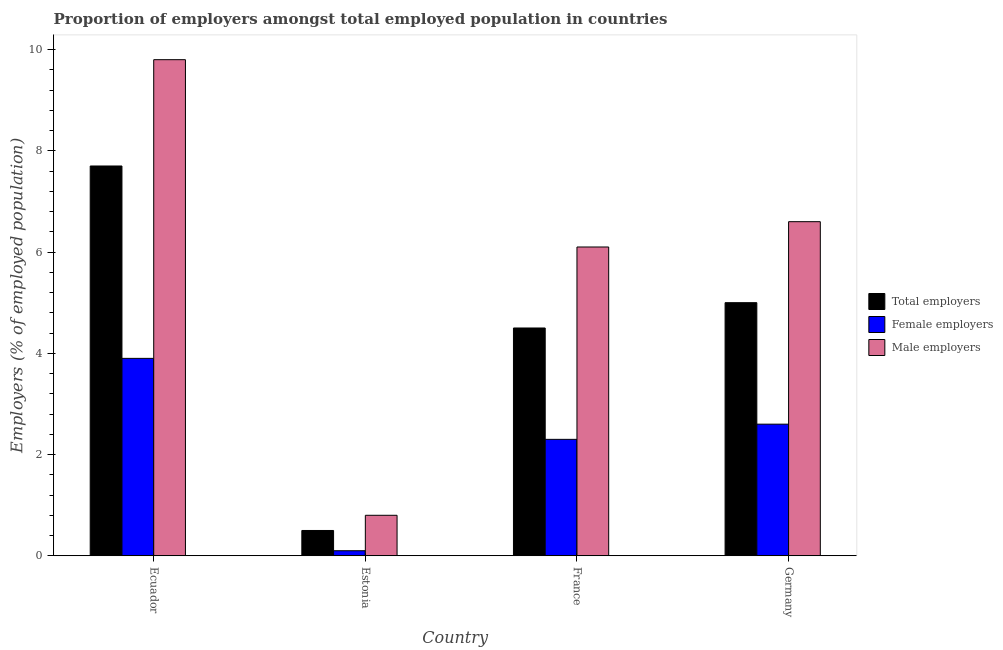How many bars are there on the 2nd tick from the left?
Your answer should be very brief. 3. What is the label of the 4th group of bars from the left?
Ensure brevity in your answer.  Germany. What is the percentage of total employers in Estonia?
Ensure brevity in your answer.  0.5. Across all countries, what is the maximum percentage of female employers?
Give a very brief answer. 3.9. In which country was the percentage of female employers maximum?
Your response must be concise. Ecuador. In which country was the percentage of total employers minimum?
Offer a very short reply. Estonia. What is the total percentage of male employers in the graph?
Make the answer very short. 23.3. What is the difference between the percentage of total employers in Ecuador and that in France?
Your answer should be compact. 3.2. What is the difference between the percentage of male employers in Ecuador and the percentage of female employers in France?
Offer a terse response. 7.5. What is the average percentage of male employers per country?
Offer a very short reply. 5.83. What is the difference between the percentage of total employers and percentage of female employers in France?
Make the answer very short. 2.2. What is the ratio of the percentage of total employers in Ecuador to that in Germany?
Your response must be concise. 1.54. What is the difference between the highest and the second highest percentage of male employers?
Provide a short and direct response. 3.2. What is the difference between the highest and the lowest percentage of total employers?
Make the answer very short. 7.2. In how many countries, is the percentage of male employers greater than the average percentage of male employers taken over all countries?
Offer a terse response. 3. What does the 2nd bar from the left in France represents?
Give a very brief answer. Female employers. What does the 1st bar from the right in France represents?
Your answer should be compact. Male employers. Is it the case that in every country, the sum of the percentage of total employers and percentage of female employers is greater than the percentage of male employers?
Provide a succinct answer. No. How many bars are there?
Provide a short and direct response. 12. Are all the bars in the graph horizontal?
Provide a succinct answer. No. What is the difference between two consecutive major ticks on the Y-axis?
Offer a terse response. 2. Does the graph contain grids?
Offer a terse response. No. Where does the legend appear in the graph?
Keep it short and to the point. Center right. What is the title of the graph?
Offer a very short reply. Proportion of employers amongst total employed population in countries. Does "Refusal of sex" appear as one of the legend labels in the graph?
Your answer should be very brief. No. What is the label or title of the X-axis?
Your answer should be very brief. Country. What is the label or title of the Y-axis?
Provide a succinct answer. Employers (% of employed population). What is the Employers (% of employed population) in Total employers in Ecuador?
Keep it short and to the point. 7.7. What is the Employers (% of employed population) of Female employers in Ecuador?
Provide a succinct answer. 3.9. What is the Employers (% of employed population) in Male employers in Ecuador?
Ensure brevity in your answer.  9.8. What is the Employers (% of employed population) in Female employers in Estonia?
Keep it short and to the point. 0.1. What is the Employers (% of employed population) of Male employers in Estonia?
Give a very brief answer. 0.8. What is the Employers (% of employed population) in Total employers in France?
Your response must be concise. 4.5. What is the Employers (% of employed population) of Female employers in France?
Your answer should be compact. 2.3. What is the Employers (% of employed population) of Male employers in France?
Give a very brief answer. 6.1. What is the Employers (% of employed population) in Total employers in Germany?
Offer a very short reply. 5. What is the Employers (% of employed population) in Female employers in Germany?
Make the answer very short. 2.6. What is the Employers (% of employed population) in Male employers in Germany?
Keep it short and to the point. 6.6. Across all countries, what is the maximum Employers (% of employed population) of Total employers?
Ensure brevity in your answer.  7.7. Across all countries, what is the maximum Employers (% of employed population) of Female employers?
Your answer should be very brief. 3.9. Across all countries, what is the maximum Employers (% of employed population) in Male employers?
Ensure brevity in your answer.  9.8. Across all countries, what is the minimum Employers (% of employed population) in Female employers?
Your answer should be compact. 0.1. Across all countries, what is the minimum Employers (% of employed population) in Male employers?
Ensure brevity in your answer.  0.8. What is the total Employers (% of employed population) in Female employers in the graph?
Your answer should be compact. 8.9. What is the total Employers (% of employed population) in Male employers in the graph?
Offer a very short reply. 23.3. What is the difference between the Employers (% of employed population) in Male employers in Ecuador and that in Estonia?
Keep it short and to the point. 9. What is the difference between the Employers (% of employed population) of Total employers in Ecuador and that in Germany?
Give a very brief answer. 2.7. What is the difference between the Employers (% of employed population) of Male employers in Ecuador and that in Germany?
Provide a succinct answer. 3.2. What is the difference between the Employers (% of employed population) in Total employers in Estonia and that in France?
Your response must be concise. -4. What is the difference between the Employers (% of employed population) of Male employers in Estonia and that in France?
Offer a very short reply. -5.3. What is the difference between the Employers (% of employed population) of Female employers in Estonia and that in Germany?
Give a very brief answer. -2.5. What is the difference between the Employers (% of employed population) in Male employers in Estonia and that in Germany?
Keep it short and to the point. -5.8. What is the difference between the Employers (% of employed population) of Total employers in France and that in Germany?
Provide a succinct answer. -0.5. What is the difference between the Employers (% of employed population) of Female employers in France and that in Germany?
Your response must be concise. -0.3. What is the difference between the Employers (% of employed population) in Male employers in France and that in Germany?
Provide a short and direct response. -0.5. What is the difference between the Employers (% of employed population) of Total employers in Ecuador and the Employers (% of employed population) of Female employers in France?
Your answer should be compact. 5.4. What is the difference between the Employers (% of employed population) of Total employers in Ecuador and the Employers (% of employed population) of Male employers in France?
Offer a terse response. 1.6. What is the difference between the Employers (% of employed population) of Female employers in Ecuador and the Employers (% of employed population) of Male employers in France?
Your response must be concise. -2.2. What is the difference between the Employers (% of employed population) in Total employers in Ecuador and the Employers (% of employed population) in Female employers in Germany?
Keep it short and to the point. 5.1. What is the difference between the Employers (% of employed population) in Total employers in Ecuador and the Employers (% of employed population) in Male employers in Germany?
Ensure brevity in your answer.  1.1. What is the difference between the Employers (% of employed population) of Total employers in Estonia and the Employers (% of employed population) of Female employers in France?
Make the answer very short. -1.8. What is the difference between the Employers (% of employed population) of Female employers in Estonia and the Employers (% of employed population) of Male employers in France?
Ensure brevity in your answer.  -6. What is the difference between the Employers (% of employed population) in Female employers in Estonia and the Employers (% of employed population) in Male employers in Germany?
Provide a succinct answer. -6.5. What is the difference between the Employers (% of employed population) in Total employers in France and the Employers (% of employed population) in Female employers in Germany?
Offer a very short reply. 1.9. What is the difference between the Employers (% of employed population) in Total employers in France and the Employers (% of employed population) in Male employers in Germany?
Provide a succinct answer. -2.1. What is the average Employers (% of employed population) in Total employers per country?
Make the answer very short. 4.42. What is the average Employers (% of employed population) of Female employers per country?
Provide a short and direct response. 2.23. What is the average Employers (% of employed population) in Male employers per country?
Make the answer very short. 5.83. What is the difference between the Employers (% of employed population) in Total employers and Employers (% of employed population) in Female employers in Ecuador?
Make the answer very short. 3.8. What is the difference between the Employers (% of employed population) in Total employers and Employers (% of employed population) in Male employers in Ecuador?
Ensure brevity in your answer.  -2.1. What is the difference between the Employers (% of employed population) of Total employers and Employers (% of employed population) of Male employers in Estonia?
Your response must be concise. -0.3. What is the difference between the Employers (% of employed population) of Total employers and Employers (% of employed population) of Female employers in France?
Make the answer very short. 2.2. What is the difference between the Employers (% of employed population) of Total employers and Employers (% of employed population) of Male employers in France?
Offer a terse response. -1.6. What is the difference between the Employers (% of employed population) in Total employers and Employers (% of employed population) in Female employers in Germany?
Your answer should be compact. 2.4. What is the ratio of the Employers (% of employed population) in Total employers in Ecuador to that in Estonia?
Offer a terse response. 15.4. What is the ratio of the Employers (% of employed population) in Female employers in Ecuador to that in Estonia?
Offer a very short reply. 39. What is the ratio of the Employers (% of employed population) in Male employers in Ecuador to that in Estonia?
Your answer should be very brief. 12.25. What is the ratio of the Employers (% of employed population) in Total employers in Ecuador to that in France?
Provide a succinct answer. 1.71. What is the ratio of the Employers (% of employed population) in Female employers in Ecuador to that in France?
Your response must be concise. 1.7. What is the ratio of the Employers (% of employed population) in Male employers in Ecuador to that in France?
Offer a very short reply. 1.61. What is the ratio of the Employers (% of employed population) in Total employers in Ecuador to that in Germany?
Offer a terse response. 1.54. What is the ratio of the Employers (% of employed population) in Female employers in Ecuador to that in Germany?
Make the answer very short. 1.5. What is the ratio of the Employers (% of employed population) of Male employers in Ecuador to that in Germany?
Offer a terse response. 1.48. What is the ratio of the Employers (% of employed population) of Female employers in Estonia to that in France?
Ensure brevity in your answer.  0.04. What is the ratio of the Employers (% of employed population) in Male employers in Estonia to that in France?
Ensure brevity in your answer.  0.13. What is the ratio of the Employers (% of employed population) in Female employers in Estonia to that in Germany?
Your response must be concise. 0.04. What is the ratio of the Employers (% of employed population) in Male employers in Estonia to that in Germany?
Provide a succinct answer. 0.12. What is the ratio of the Employers (% of employed population) of Female employers in France to that in Germany?
Your response must be concise. 0.88. What is the ratio of the Employers (% of employed population) of Male employers in France to that in Germany?
Offer a terse response. 0.92. What is the difference between the highest and the second highest Employers (% of employed population) in Female employers?
Your answer should be compact. 1.3. What is the difference between the highest and the lowest Employers (% of employed population) of Total employers?
Keep it short and to the point. 7.2. What is the difference between the highest and the lowest Employers (% of employed population) of Male employers?
Your response must be concise. 9. 